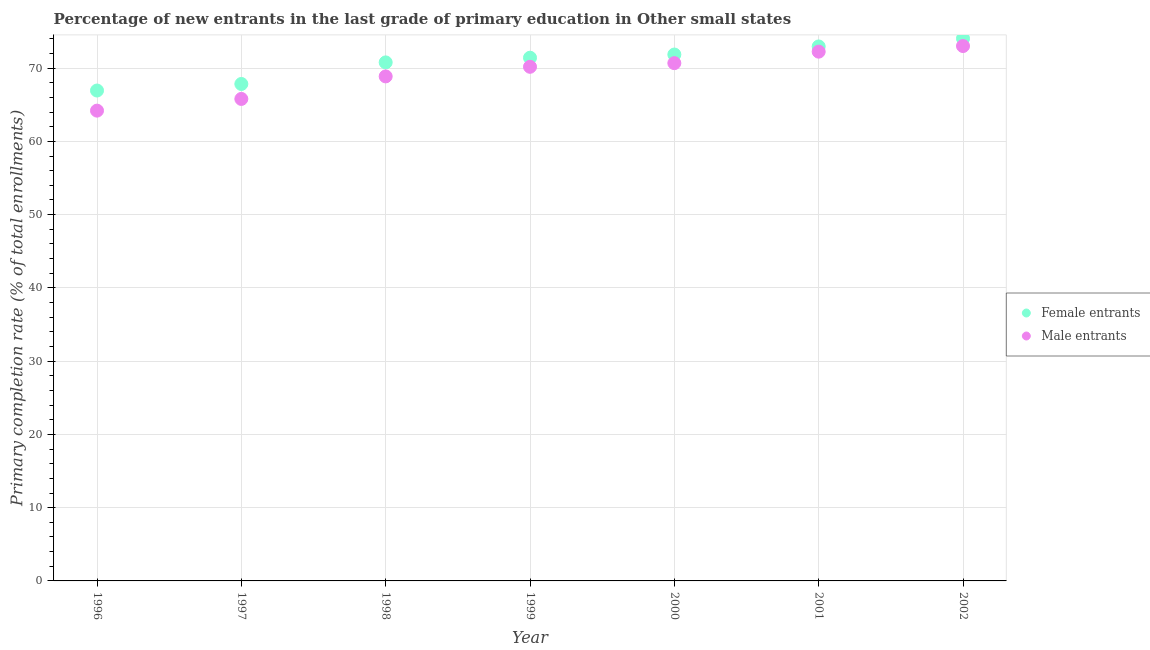Is the number of dotlines equal to the number of legend labels?
Give a very brief answer. Yes. What is the primary completion rate of female entrants in 1996?
Your response must be concise. 66.94. Across all years, what is the maximum primary completion rate of female entrants?
Your response must be concise. 74.05. Across all years, what is the minimum primary completion rate of female entrants?
Ensure brevity in your answer.  66.94. In which year was the primary completion rate of female entrants minimum?
Provide a succinct answer. 1996. What is the total primary completion rate of female entrants in the graph?
Offer a very short reply. 495.85. What is the difference between the primary completion rate of female entrants in 2001 and that in 2002?
Provide a short and direct response. -1.09. What is the difference between the primary completion rate of male entrants in 2001 and the primary completion rate of female entrants in 2000?
Provide a short and direct response. 0.39. What is the average primary completion rate of male entrants per year?
Give a very brief answer. 69.29. In the year 2000, what is the difference between the primary completion rate of female entrants and primary completion rate of male entrants?
Offer a very short reply. 1.17. What is the ratio of the primary completion rate of female entrants in 1997 to that in 1998?
Your response must be concise. 0.96. Is the primary completion rate of female entrants in 1997 less than that in 1998?
Provide a succinct answer. Yes. Is the difference between the primary completion rate of male entrants in 1996 and 2000 greater than the difference between the primary completion rate of female entrants in 1996 and 2000?
Make the answer very short. No. What is the difference between the highest and the second highest primary completion rate of male entrants?
Make the answer very short. 0.77. What is the difference between the highest and the lowest primary completion rate of female entrants?
Offer a terse response. 7.11. Is the sum of the primary completion rate of male entrants in 1999 and 2000 greater than the maximum primary completion rate of female entrants across all years?
Ensure brevity in your answer.  Yes. Does the primary completion rate of female entrants monotonically increase over the years?
Make the answer very short. Yes. Is the primary completion rate of male entrants strictly greater than the primary completion rate of female entrants over the years?
Make the answer very short. No. Is the primary completion rate of male entrants strictly less than the primary completion rate of female entrants over the years?
Ensure brevity in your answer.  Yes. How many dotlines are there?
Make the answer very short. 2. What is the difference between two consecutive major ticks on the Y-axis?
Offer a terse response. 10. Are the values on the major ticks of Y-axis written in scientific E-notation?
Offer a terse response. No. Does the graph contain grids?
Keep it short and to the point. Yes. How many legend labels are there?
Keep it short and to the point. 2. What is the title of the graph?
Offer a very short reply. Percentage of new entrants in the last grade of primary education in Other small states. Does "Attending school" appear as one of the legend labels in the graph?
Your response must be concise. No. What is the label or title of the X-axis?
Give a very brief answer. Year. What is the label or title of the Y-axis?
Give a very brief answer. Primary completion rate (% of total enrollments). What is the Primary completion rate (% of total enrollments) in Female entrants in 1996?
Provide a succinct answer. 66.94. What is the Primary completion rate (% of total enrollments) in Male entrants in 1996?
Your answer should be compact. 64.2. What is the Primary completion rate (% of total enrollments) of Female entrants in 1997?
Offer a very short reply. 67.84. What is the Primary completion rate (% of total enrollments) in Male entrants in 1997?
Your answer should be compact. 65.8. What is the Primary completion rate (% of total enrollments) in Female entrants in 1998?
Offer a very short reply. 70.78. What is the Primary completion rate (% of total enrollments) in Male entrants in 1998?
Your answer should be compact. 68.87. What is the Primary completion rate (% of total enrollments) of Female entrants in 1999?
Provide a succinct answer. 71.42. What is the Primary completion rate (% of total enrollments) in Male entrants in 1999?
Offer a very short reply. 70.18. What is the Primary completion rate (% of total enrollments) in Female entrants in 2000?
Offer a terse response. 71.86. What is the Primary completion rate (% of total enrollments) of Male entrants in 2000?
Your answer should be very brief. 70.68. What is the Primary completion rate (% of total enrollments) in Female entrants in 2001?
Provide a short and direct response. 72.96. What is the Primary completion rate (% of total enrollments) in Male entrants in 2001?
Make the answer very short. 72.25. What is the Primary completion rate (% of total enrollments) in Female entrants in 2002?
Provide a short and direct response. 74.05. What is the Primary completion rate (% of total enrollments) in Male entrants in 2002?
Your answer should be compact. 73.02. Across all years, what is the maximum Primary completion rate (% of total enrollments) in Female entrants?
Offer a very short reply. 74.05. Across all years, what is the maximum Primary completion rate (% of total enrollments) of Male entrants?
Your response must be concise. 73.02. Across all years, what is the minimum Primary completion rate (% of total enrollments) of Female entrants?
Give a very brief answer. 66.94. Across all years, what is the minimum Primary completion rate (% of total enrollments) in Male entrants?
Keep it short and to the point. 64.2. What is the total Primary completion rate (% of total enrollments) in Female entrants in the graph?
Make the answer very short. 495.85. What is the total Primary completion rate (% of total enrollments) of Male entrants in the graph?
Your answer should be compact. 485. What is the difference between the Primary completion rate (% of total enrollments) of Female entrants in 1996 and that in 1997?
Ensure brevity in your answer.  -0.89. What is the difference between the Primary completion rate (% of total enrollments) in Male entrants in 1996 and that in 1997?
Keep it short and to the point. -1.6. What is the difference between the Primary completion rate (% of total enrollments) in Female entrants in 1996 and that in 1998?
Give a very brief answer. -3.84. What is the difference between the Primary completion rate (% of total enrollments) in Male entrants in 1996 and that in 1998?
Provide a short and direct response. -4.67. What is the difference between the Primary completion rate (% of total enrollments) in Female entrants in 1996 and that in 1999?
Provide a succinct answer. -4.48. What is the difference between the Primary completion rate (% of total enrollments) of Male entrants in 1996 and that in 1999?
Ensure brevity in your answer.  -5.98. What is the difference between the Primary completion rate (% of total enrollments) in Female entrants in 1996 and that in 2000?
Ensure brevity in your answer.  -4.91. What is the difference between the Primary completion rate (% of total enrollments) of Male entrants in 1996 and that in 2000?
Ensure brevity in your answer.  -6.48. What is the difference between the Primary completion rate (% of total enrollments) of Female entrants in 1996 and that in 2001?
Make the answer very short. -6.02. What is the difference between the Primary completion rate (% of total enrollments) of Male entrants in 1996 and that in 2001?
Make the answer very short. -8.05. What is the difference between the Primary completion rate (% of total enrollments) in Female entrants in 1996 and that in 2002?
Offer a very short reply. -7.11. What is the difference between the Primary completion rate (% of total enrollments) in Male entrants in 1996 and that in 2002?
Keep it short and to the point. -8.82. What is the difference between the Primary completion rate (% of total enrollments) in Female entrants in 1997 and that in 1998?
Offer a very short reply. -2.95. What is the difference between the Primary completion rate (% of total enrollments) in Male entrants in 1997 and that in 1998?
Your response must be concise. -3.08. What is the difference between the Primary completion rate (% of total enrollments) of Female entrants in 1997 and that in 1999?
Your answer should be very brief. -3.59. What is the difference between the Primary completion rate (% of total enrollments) in Male entrants in 1997 and that in 1999?
Offer a terse response. -4.39. What is the difference between the Primary completion rate (% of total enrollments) of Female entrants in 1997 and that in 2000?
Offer a very short reply. -4.02. What is the difference between the Primary completion rate (% of total enrollments) of Male entrants in 1997 and that in 2000?
Your answer should be compact. -4.89. What is the difference between the Primary completion rate (% of total enrollments) of Female entrants in 1997 and that in 2001?
Provide a short and direct response. -5.12. What is the difference between the Primary completion rate (% of total enrollments) in Male entrants in 1997 and that in 2001?
Your answer should be compact. -6.45. What is the difference between the Primary completion rate (% of total enrollments) in Female entrants in 1997 and that in 2002?
Make the answer very short. -6.21. What is the difference between the Primary completion rate (% of total enrollments) of Male entrants in 1997 and that in 2002?
Keep it short and to the point. -7.22. What is the difference between the Primary completion rate (% of total enrollments) in Female entrants in 1998 and that in 1999?
Keep it short and to the point. -0.64. What is the difference between the Primary completion rate (% of total enrollments) in Male entrants in 1998 and that in 1999?
Provide a succinct answer. -1.31. What is the difference between the Primary completion rate (% of total enrollments) of Female entrants in 1998 and that in 2000?
Give a very brief answer. -1.07. What is the difference between the Primary completion rate (% of total enrollments) in Male entrants in 1998 and that in 2000?
Give a very brief answer. -1.81. What is the difference between the Primary completion rate (% of total enrollments) in Female entrants in 1998 and that in 2001?
Ensure brevity in your answer.  -2.18. What is the difference between the Primary completion rate (% of total enrollments) of Male entrants in 1998 and that in 2001?
Make the answer very short. -3.38. What is the difference between the Primary completion rate (% of total enrollments) of Female entrants in 1998 and that in 2002?
Give a very brief answer. -3.26. What is the difference between the Primary completion rate (% of total enrollments) in Male entrants in 1998 and that in 2002?
Keep it short and to the point. -4.15. What is the difference between the Primary completion rate (% of total enrollments) of Female entrants in 1999 and that in 2000?
Offer a very short reply. -0.43. What is the difference between the Primary completion rate (% of total enrollments) of Male entrants in 1999 and that in 2000?
Offer a terse response. -0.5. What is the difference between the Primary completion rate (% of total enrollments) of Female entrants in 1999 and that in 2001?
Your response must be concise. -1.54. What is the difference between the Primary completion rate (% of total enrollments) in Male entrants in 1999 and that in 2001?
Provide a short and direct response. -2.07. What is the difference between the Primary completion rate (% of total enrollments) in Female entrants in 1999 and that in 2002?
Your response must be concise. -2.63. What is the difference between the Primary completion rate (% of total enrollments) in Male entrants in 1999 and that in 2002?
Offer a very short reply. -2.83. What is the difference between the Primary completion rate (% of total enrollments) of Female entrants in 2000 and that in 2001?
Make the answer very short. -1.1. What is the difference between the Primary completion rate (% of total enrollments) of Male entrants in 2000 and that in 2001?
Keep it short and to the point. -1.57. What is the difference between the Primary completion rate (% of total enrollments) of Female entrants in 2000 and that in 2002?
Offer a terse response. -2.19. What is the difference between the Primary completion rate (% of total enrollments) of Male entrants in 2000 and that in 2002?
Provide a succinct answer. -2.33. What is the difference between the Primary completion rate (% of total enrollments) in Female entrants in 2001 and that in 2002?
Provide a succinct answer. -1.09. What is the difference between the Primary completion rate (% of total enrollments) of Male entrants in 2001 and that in 2002?
Keep it short and to the point. -0.77. What is the difference between the Primary completion rate (% of total enrollments) of Female entrants in 1996 and the Primary completion rate (% of total enrollments) of Male entrants in 1997?
Your response must be concise. 1.15. What is the difference between the Primary completion rate (% of total enrollments) of Female entrants in 1996 and the Primary completion rate (% of total enrollments) of Male entrants in 1998?
Offer a very short reply. -1.93. What is the difference between the Primary completion rate (% of total enrollments) in Female entrants in 1996 and the Primary completion rate (% of total enrollments) in Male entrants in 1999?
Provide a short and direct response. -3.24. What is the difference between the Primary completion rate (% of total enrollments) of Female entrants in 1996 and the Primary completion rate (% of total enrollments) of Male entrants in 2000?
Your response must be concise. -3.74. What is the difference between the Primary completion rate (% of total enrollments) in Female entrants in 1996 and the Primary completion rate (% of total enrollments) in Male entrants in 2001?
Ensure brevity in your answer.  -5.31. What is the difference between the Primary completion rate (% of total enrollments) of Female entrants in 1996 and the Primary completion rate (% of total enrollments) of Male entrants in 2002?
Provide a short and direct response. -6.07. What is the difference between the Primary completion rate (% of total enrollments) in Female entrants in 1997 and the Primary completion rate (% of total enrollments) in Male entrants in 1998?
Offer a terse response. -1.03. What is the difference between the Primary completion rate (% of total enrollments) in Female entrants in 1997 and the Primary completion rate (% of total enrollments) in Male entrants in 1999?
Your answer should be very brief. -2.34. What is the difference between the Primary completion rate (% of total enrollments) in Female entrants in 1997 and the Primary completion rate (% of total enrollments) in Male entrants in 2000?
Offer a very short reply. -2.85. What is the difference between the Primary completion rate (% of total enrollments) of Female entrants in 1997 and the Primary completion rate (% of total enrollments) of Male entrants in 2001?
Your answer should be very brief. -4.41. What is the difference between the Primary completion rate (% of total enrollments) in Female entrants in 1997 and the Primary completion rate (% of total enrollments) in Male entrants in 2002?
Give a very brief answer. -5.18. What is the difference between the Primary completion rate (% of total enrollments) in Female entrants in 1998 and the Primary completion rate (% of total enrollments) in Male entrants in 1999?
Keep it short and to the point. 0.6. What is the difference between the Primary completion rate (% of total enrollments) of Female entrants in 1998 and the Primary completion rate (% of total enrollments) of Male entrants in 2000?
Your response must be concise. 0.1. What is the difference between the Primary completion rate (% of total enrollments) in Female entrants in 1998 and the Primary completion rate (% of total enrollments) in Male entrants in 2001?
Ensure brevity in your answer.  -1.47. What is the difference between the Primary completion rate (% of total enrollments) in Female entrants in 1998 and the Primary completion rate (% of total enrollments) in Male entrants in 2002?
Your answer should be compact. -2.23. What is the difference between the Primary completion rate (% of total enrollments) of Female entrants in 1999 and the Primary completion rate (% of total enrollments) of Male entrants in 2000?
Offer a very short reply. 0.74. What is the difference between the Primary completion rate (% of total enrollments) of Female entrants in 1999 and the Primary completion rate (% of total enrollments) of Male entrants in 2001?
Provide a succinct answer. -0.83. What is the difference between the Primary completion rate (% of total enrollments) of Female entrants in 1999 and the Primary completion rate (% of total enrollments) of Male entrants in 2002?
Your response must be concise. -1.59. What is the difference between the Primary completion rate (% of total enrollments) of Female entrants in 2000 and the Primary completion rate (% of total enrollments) of Male entrants in 2001?
Your response must be concise. -0.39. What is the difference between the Primary completion rate (% of total enrollments) in Female entrants in 2000 and the Primary completion rate (% of total enrollments) in Male entrants in 2002?
Provide a succinct answer. -1.16. What is the difference between the Primary completion rate (% of total enrollments) in Female entrants in 2001 and the Primary completion rate (% of total enrollments) in Male entrants in 2002?
Keep it short and to the point. -0.06. What is the average Primary completion rate (% of total enrollments) in Female entrants per year?
Your answer should be very brief. 70.84. What is the average Primary completion rate (% of total enrollments) of Male entrants per year?
Your answer should be very brief. 69.29. In the year 1996, what is the difference between the Primary completion rate (% of total enrollments) of Female entrants and Primary completion rate (% of total enrollments) of Male entrants?
Ensure brevity in your answer.  2.74. In the year 1997, what is the difference between the Primary completion rate (% of total enrollments) in Female entrants and Primary completion rate (% of total enrollments) in Male entrants?
Give a very brief answer. 2.04. In the year 1998, what is the difference between the Primary completion rate (% of total enrollments) in Female entrants and Primary completion rate (% of total enrollments) in Male entrants?
Provide a succinct answer. 1.91. In the year 1999, what is the difference between the Primary completion rate (% of total enrollments) of Female entrants and Primary completion rate (% of total enrollments) of Male entrants?
Provide a short and direct response. 1.24. In the year 2000, what is the difference between the Primary completion rate (% of total enrollments) in Female entrants and Primary completion rate (% of total enrollments) in Male entrants?
Your response must be concise. 1.17. In the year 2001, what is the difference between the Primary completion rate (% of total enrollments) in Female entrants and Primary completion rate (% of total enrollments) in Male entrants?
Give a very brief answer. 0.71. In the year 2002, what is the difference between the Primary completion rate (% of total enrollments) of Female entrants and Primary completion rate (% of total enrollments) of Male entrants?
Ensure brevity in your answer.  1.03. What is the ratio of the Primary completion rate (% of total enrollments) of Male entrants in 1996 to that in 1997?
Keep it short and to the point. 0.98. What is the ratio of the Primary completion rate (% of total enrollments) of Female entrants in 1996 to that in 1998?
Give a very brief answer. 0.95. What is the ratio of the Primary completion rate (% of total enrollments) in Male entrants in 1996 to that in 1998?
Provide a succinct answer. 0.93. What is the ratio of the Primary completion rate (% of total enrollments) of Female entrants in 1996 to that in 1999?
Give a very brief answer. 0.94. What is the ratio of the Primary completion rate (% of total enrollments) of Male entrants in 1996 to that in 1999?
Provide a succinct answer. 0.91. What is the ratio of the Primary completion rate (% of total enrollments) in Female entrants in 1996 to that in 2000?
Your answer should be compact. 0.93. What is the ratio of the Primary completion rate (% of total enrollments) in Male entrants in 1996 to that in 2000?
Offer a very short reply. 0.91. What is the ratio of the Primary completion rate (% of total enrollments) of Female entrants in 1996 to that in 2001?
Offer a very short reply. 0.92. What is the ratio of the Primary completion rate (% of total enrollments) in Male entrants in 1996 to that in 2001?
Offer a very short reply. 0.89. What is the ratio of the Primary completion rate (% of total enrollments) of Female entrants in 1996 to that in 2002?
Provide a short and direct response. 0.9. What is the ratio of the Primary completion rate (% of total enrollments) of Male entrants in 1996 to that in 2002?
Keep it short and to the point. 0.88. What is the ratio of the Primary completion rate (% of total enrollments) in Female entrants in 1997 to that in 1998?
Your answer should be compact. 0.96. What is the ratio of the Primary completion rate (% of total enrollments) of Male entrants in 1997 to that in 1998?
Provide a short and direct response. 0.96. What is the ratio of the Primary completion rate (% of total enrollments) of Female entrants in 1997 to that in 1999?
Your answer should be compact. 0.95. What is the ratio of the Primary completion rate (% of total enrollments) of Male entrants in 1997 to that in 1999?
Ensure brevity in your answer.  0.94. What is the ratio of the Primary completion rate (% of total enrollments) of Female entrants in 1997 to that in 2000?
Make the answer very short. 0.94. What is the ratio of the Primary completion rate (% of total enrollments) in Male entrants in 1997 to that in 2000?
Offer a terse response. 0.93. What is the ratio of the Primary completion rate (% of total enrollments) of Female entrants in 1997 to that in 2001?
Your answer should be very brief. 0.93. What is the ratio of the Primary completion rate (% of total enrollments) in Male entrants in 1997 to that in 2001?
Ensure brevity in your answer.  0.91. What is the ratio of the Primary completion rate (% of total enrollments) of Female entrants in 1997 to that in 2002?
Provide a succinct answer. 0.92. What is the ratio of the Primary completion rate (% of total enrollments) in Male entrants in 1997 to that in 2002?
Provide a succinct answer. 0.9. What is the ratio of the Primary completion rate (% of total enrollments) of Male entrants in 1998 to that in 1999?
Give a very brief answer. 0.98. What is the ratio of the Primary completion rate (% of total enrollments) of Female entrants in 1998 to that in 2000?
Your response must be concise. 0.99. What is the ratio of the Primary completion rate (% of total enrollments) in Male entrants in 1998 to that in 2000?
Keep it short and to the point. 0.97. What is the ratio of the Primary completion rate (% of total enrollments) in Female entrants in 1998 to that in 2001?
Ensure brevity in your answer.  0.97. What is the ratio of the Primary completion rate (% of total enrollments) of Male entrants in 1998 to that in 2001?
Ensure brevity in your answer.  0.95. What is the ratio of the Primary completion rate (% of total enrollments) of Female entrants in 1998 to that in 2002?
Give a very brief answer. 0.96. What is the ratio of the Primary completion rate (% of total enrollments) in Male entrants in 1998 to that in 2002?
Your response must be concise. 0.94. What is the ratio of the Primary completion rate (% of total enrollments) of Female entrants in 1999 to that in 2000?
Give a very brief answer. 0.99. What is the ratio of the Primary completion rate (% of total enrollments) of Female entrants in 1999 to that in 2001?
Your answer should be compact. 0.98. What is the ratio of the Primary completion rate (% of total enrollments) of Male entrants in 1999 to that in 2001?
Provide a succinct answer. 0.97. What is the ratio of the Primary completion rate (% of total enrollments) in Female entrants in 1999 to that in 2002?
Provide a succinct answer. 0.96. What is the ratio of the Primary completion rate (% of total enrollments) of Male entrants in 1999 to that in 2002?
Keep it short and to the point. 0.96. What is the ratio of the Primary completion rate (% of total enrollments) in Female entrants in 2000 to that in 2001?
Your response must be concise. 0.98. What is the ratio of the Primary completion rate (% of total enrollments) of Male entrants in 2000 to that in 2001?
Keep it short and to the point. 0.98. What is the ratio of the Primary completion rate (% of total enrollments) in Female entrants in 2000 to that in 2002?
Offer a very short reply. 0.97. What is the ratio of the Primary completion rate (% of total enrollments) in Male entrants in 2000 to that in 2002?
Provide a short and direct response. 0.97. What is the ratio of the Primary completion rate (% of total enrollments) of Female entrants in 2001 to that in 2002?
Make the answer very short. 0.99. What is the difference between the highest and the second highest Primary completion rate (% of total enrollments) of Female entrants?
Give a very brief answer. 1.09. What is the difference between the highest and the second highest Primary completion rate (% of total enrollments) of Male entrants?
Provide a succinct answer. 0.77. What is the difference between the highest and the lowest Primary completion rate (% of total enrollments) in Female entrants?
Make the answer very short. 7.11. What is the difference between the highest and the lowest Primary completion rate (% of total enrollments) in Male entrants?
Your answer should be compact. 8.82. 